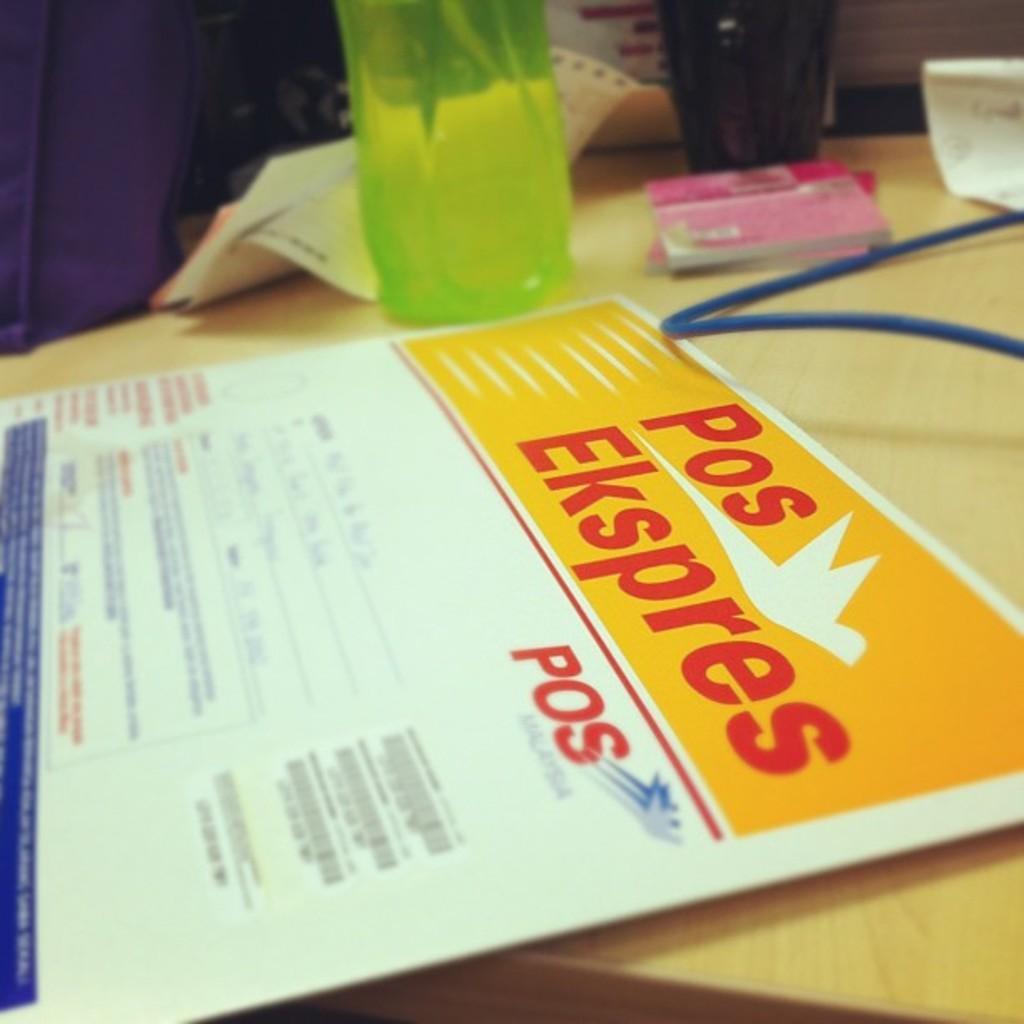Can you describe this image briefly? This picture shows a courier and we see a water bottle and a cup and we see couple of books and a paper on the table. 